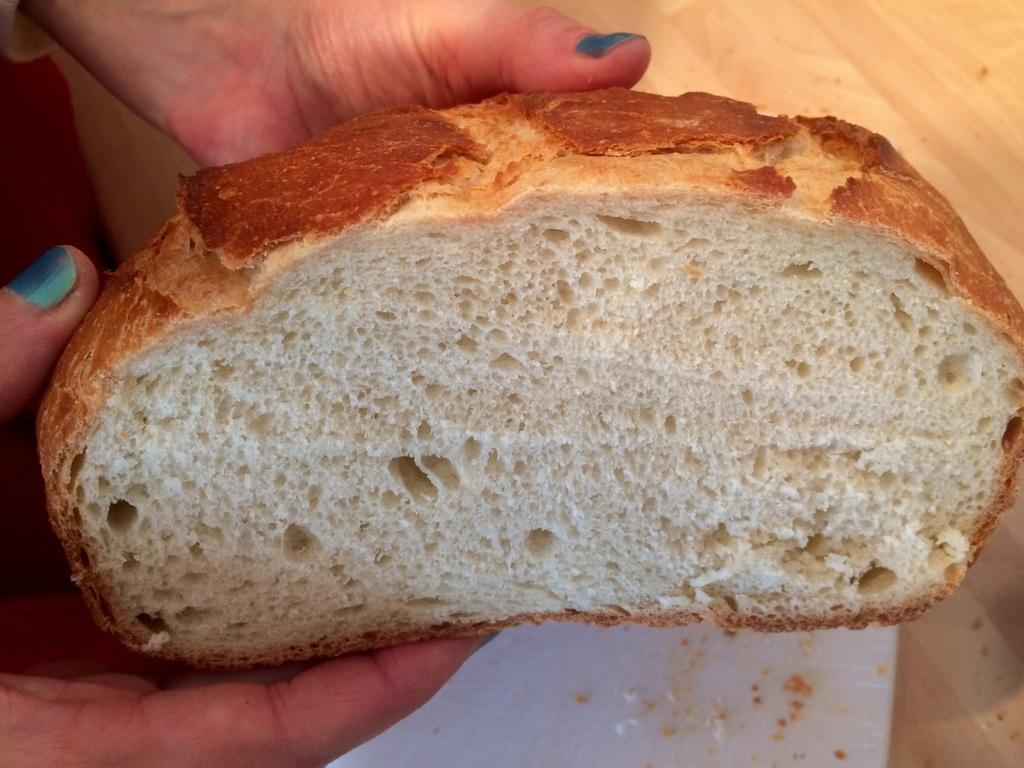What is being held by the hands in the image? The hands are holding a bread piece. What is located under the bread piece? There is a white object under the bread. What type of surface can be seen in the image? The wooden surface is visible in the image. What type of pleasure can be seen on the cat's face in the image? There is no cat present in the image, so it is not possible to determine any pleasure on a cat's face. 